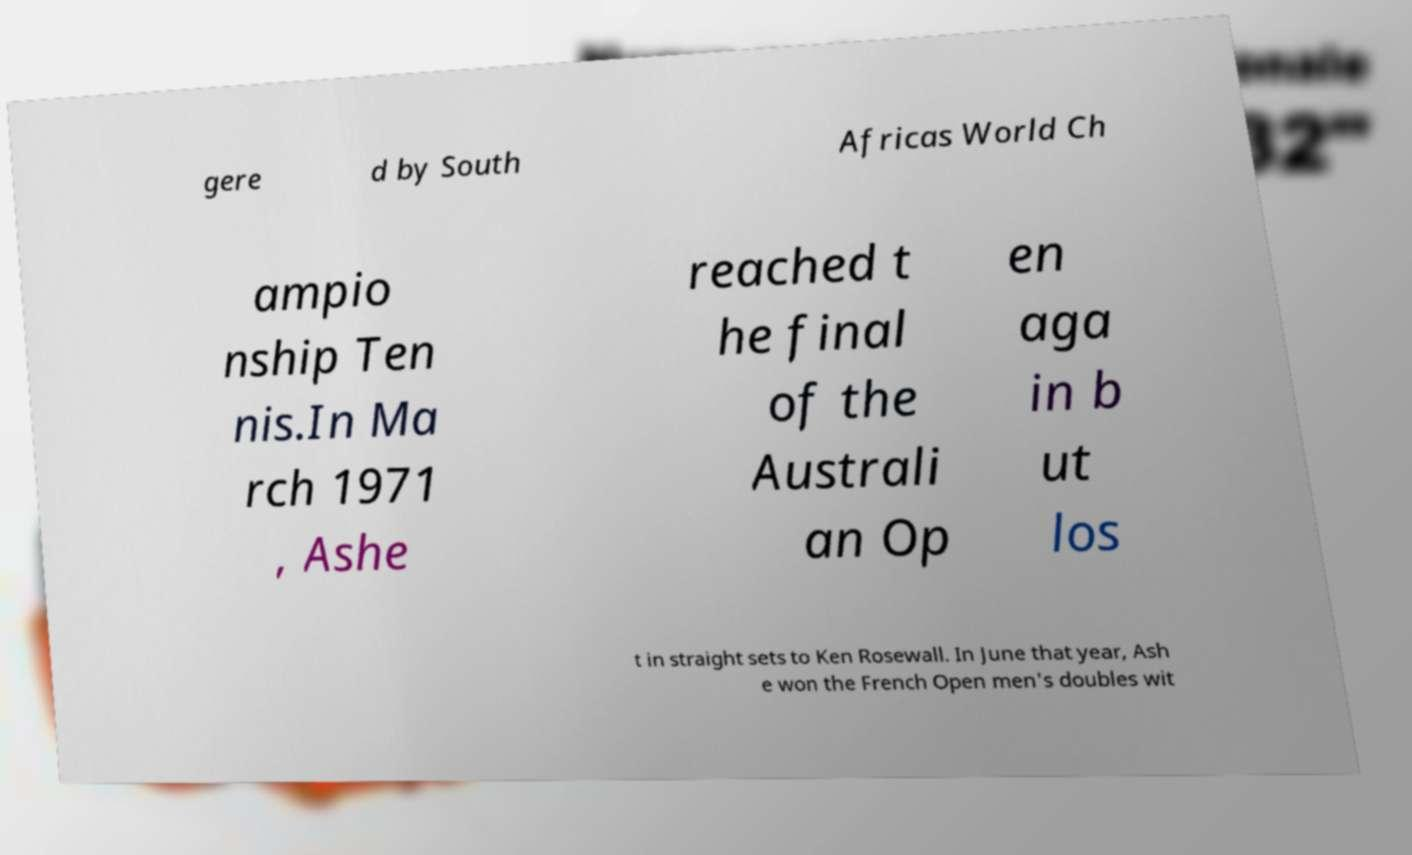Please identify and transcribe the text found in this image. gere d by South Africas World Ch ampio nship Ten nis.In Ma rch 1971 , Ashe reached t he final of the Australi an Op en aga in b ut los t in straight sets to Ken Rosewall. In June that year, Ash e won the French Open men's doubles wit 